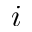<formula> <loc_0><loc_0><loc_500><loc_500>i</formula> 